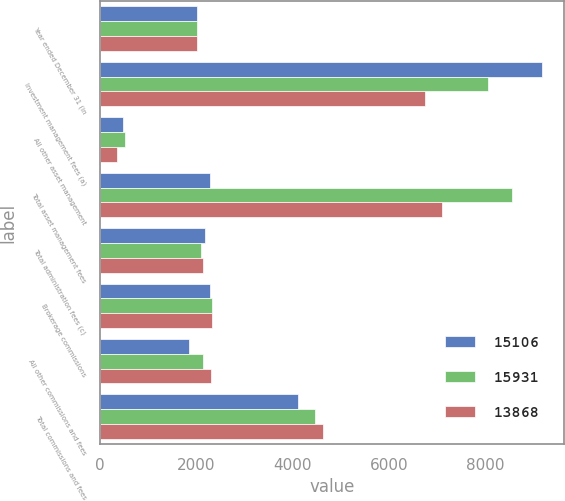Convert chart. <chart><loc_0><loc_0><loc_500><loc_500><stacked_bar_chart><ecel><fcel>Year ended December 31 (in<fcel>Investment management fees (a)<fcel>All other asset management<fcel>Total asset management fees<fcel>Total administration fees (c)<fcel>Brokerage commissions<fcel>All other commissions and fees<fcel>Total commissions and fees<nl><fcel>15106<fcel>2014<fcel>9169<fcel>477<fcel>2270<fcel>2179<fcel>2270<fcel>1836<fcel>4106<nl><fcel>15931<fcel>2013<fcel>8044<fcel>505<fcel>8549<fcel>2101<fcel>2321<fcel>2135<fcel>4456<nl><fcel>13868<fcel>2012<fcel>6744<fcel>357<fcel>7101<fcel>2135<fcel>2331<fcel>2301<fcel>4632<nl></chart> 